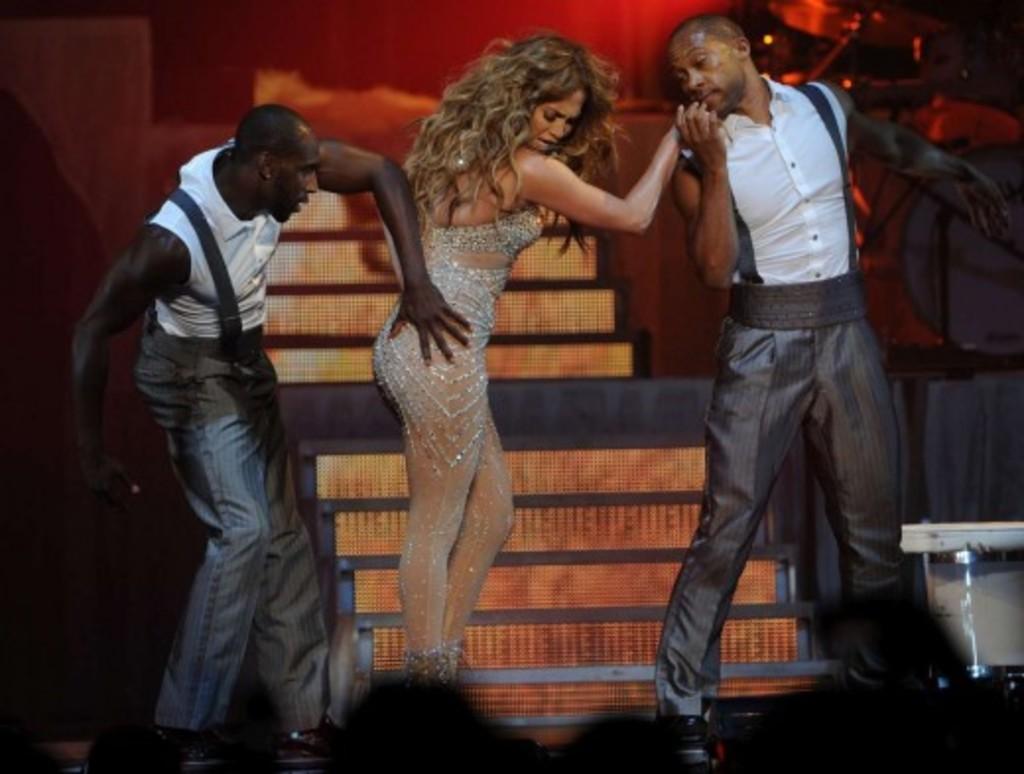Could you give a brief overview of what you see in this image? In this image, we can see three people are standing. Background we can see stairs, musical instrument. 